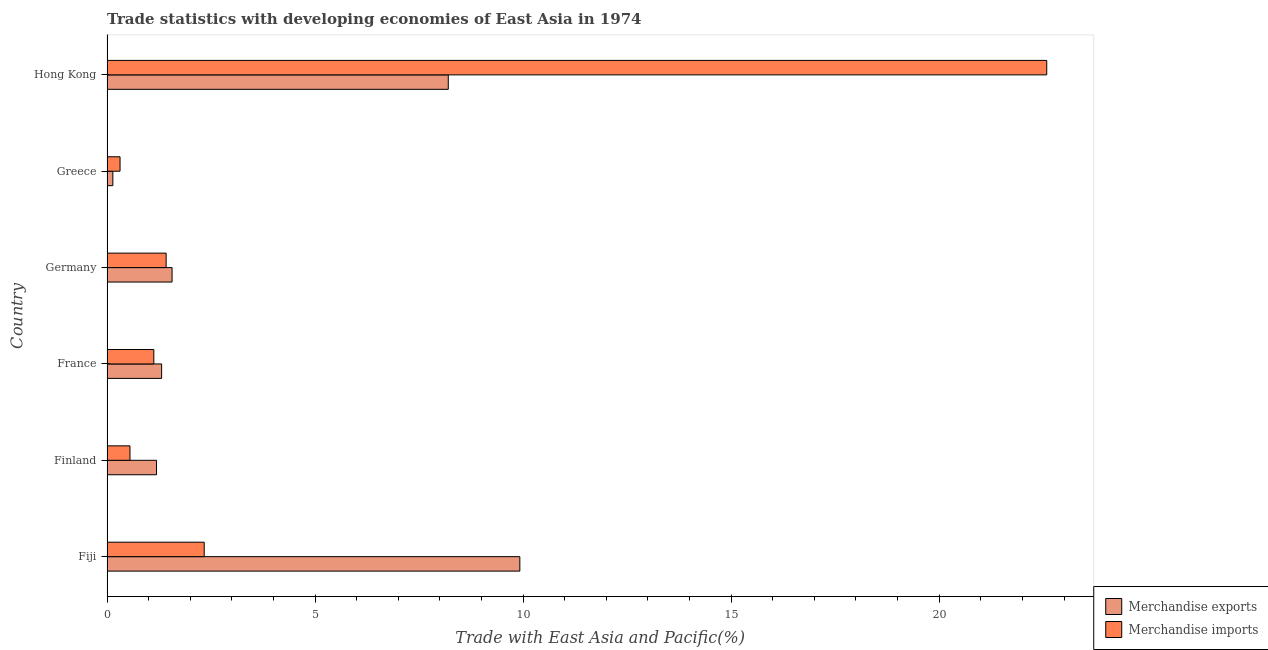How many different coloured bars are there?
Provide a succinct answer. 2. How many groups of bars are there?
Provide a short and direct response. 6. Are the number of bars per tick equal to the number of legend labels?
Your response must be concise. Yes. How many bars are there on the 3rd tick from the top?
Give a very brief answer. 2. How many bars are there on the 1st tick from the bottom?
Your response must be concise. 2. What is the label of the 1st group of bars from the top?
Ensure brevity in your answer.  Hong Kong. What is the merchandise exports in Finland?
Keep it short and to the point. 1.19. Across all countries, what is the maximum merchandise imports?
Make the answer very short. 22.59. Across all countries, what is the minimum merchandise imports?
Ensure brevity in your answer.  0.31. In which country was the merchandise exports maximum?
Offer a very short reply. Fiji. What is the total merchandise exports in the graph?
Your answer should be very brief. 22.33. What is the difference between the merchandise imports in Finland and that in Germany?
Make the answer very short. -0.87. What is the difference between the merchandise imports in Fiji and the merchandise exports in Hong Kong?
Give a very brief answer. -5.87. What is the average merchandise imports per country?
Provide a short and direct response. 4.72. What is the difference between the merchandise exports and merchandise imports in Finland?
Provide a succinct answer. 0.64. In how many countries, is the merchandise exports greater than 5 %?
Offer a very short reply. 2. What is the ratio of the merchandise imports in Finland to that in Greece?
Provide a short and direct response. 1.76. Is the merchandise exports in Fiji less than that in Finland?
Keep it short and to the point. No. What is the difference between the highest and the second highest merchandise imports?
Offer a very short reply. 20.25. What is the difference between the highest and the lowest merchandise imports?
Provide a succinct answer. 22.27. In how many countries, is the merchandise imports greater than the average merchandise imports taken over all countries?
Provide a short and direct response. 1. Is the sum of the merchandise exports in Germany and Hong Kong greater than the maximum merchandise imports across all countries?
Your response must be concise. No. What does the 1st bar from the top in Fiji represents?
Offer a very short reply. Merchandise imports. What is the difference between two consecutive major ticks on the X-axis?
Keep it short and to the point. 5. Are the values on the major ticks of X-axis written in scientific E-notation?
Your response must be concise. No. What is the title of the graph?
Keep it short and to the point. Trade statistics with developing economies of East Asia in 1974. What is the label or title of the X-axis?
Offer a very short reply. Trade with East Asia and Pacific(%). What is the label or title of the Y-axis?
Offer a terse response. Country. What is the Trade with East Asia and Pacific(%) of Merchandise exports in Fiji?
Make the answer very short. 9.92. What is the Trade with East Asia and Pacific(%) of Merchandise imports in Fiji?
Offer a terse response. 2.34. What is the Trade with East Asia and Pacific(%) in Merchandise exports in Finland?
Your answer should be compact. 1.19. What is the Trade with East Asia and Pacific(%) in Merchandise imports in Finland?
Make the answer very short. 0.55. What is the Trade with East Asia and Pacific(%) in Merchandise exports in France?
Give a very brief answer. 1.31. What is the Trade with East Asia and Pacific(%) in Merchandise imports in France?
Offer a very short reply. 1.13. What is the Trade with East Asia and Pacific(%) of Merchandise exports in Germany?
Offer a terse response. 1.56. What is the Trade with East Asia and Pacific(%) in Merchandise imports in Germany?
Make the answer very short. 1.42. What is the Trade with East Asia and Pacific(%) in Merchandise exports in Greece?
Offer a very short reply. 0.14. What is the Trade with East Asia and Pacific(%) in Merchandise imports in Greece?
Keep it short and to the point. 0.31. What is the Trade with East Asia and Pacific(%) of Merchandise exports in Hong Kong?
Your answer should be very brief. 8.2. What is the Trade with East Asia and Pacific(%) in Merchandise imports in Hong Kong?
Your response must be concise. 22.59. Across all countries, what is the maximum Trade with East Asia and Pacific(%) in Merchandise exports?
Provide a succinct answer. 9.92. Across all countries, what is the maximum Trade with East Asia and Pacific(%) of Merchandise imports?
Provide a short and direct response. 22.59. Across all countries, what is the minimum Trade with East Asia and Pacific(%) in Merchandise exports?
Make the answer very short. 0.14. Across all countries, what is the minimum Trade with East Asia and Pacific(%) of Merchandise imports?
Your answer should be very brief. 0.31. What is the total Trade with East Asia and Pacific(%) in Merchandise exports in the graph?
Offer a terse response. 22.33. What is the total Trade with East Asia and Pacific(%) of Merchandise imports in the graph?
Your answer should be very brief. 28.33. What is the difference between the Trade with East Asia and Pacific(%) in Merchandise exports in Fiji and that in Finland?
Your answer should be very brief. 8.73. What is the difference between the Trade with East Asia and Pacific(%) in Merchandise imports in Fiji and that in Finland?
Keep it short and to the point. 1.78. What is the difference between the Trade with East Asia and Pacific(%) in Merchandise exports in Fiji and that in France?
Make the answer very short. 8.61. What is the difference between the Trade with East Asia and Pacific(%) of Merchandise imports in Fiji and that in France?
Provide a succinct answer. 1.21. What is the difference between the Trade with East Asia and Pacific(%) of Merchandise exports in Fiji and that in Germany?
Make the answer very short. 8.36. What is the difference between the Trade with East Asia and Pacific(%) in Merchandise imports in Fiji and that in Germany?
Provide a succinct answer. 0.92. What is the difference between the Trade with East Asia and Pacific(%) in Merchandise exports in Fiji and that in Greece?
Your answer should be compact. 9.78. What is the difference between the Trade with East Asia and Pacific(%) of Merchandise imports in Fiji and that in Greece?
Make the answer very short. 2.02. What is the difference between the Trade with East Asia and Pacific(%) of Merchandise exports in Fiji and that in Hong Kong?
Offer a terse response. 1.72. What is the difference between the Trade with East Asia and Pacific(%) in Merchandise imports in Fiji and that in Hong Kong?
Your response must be concise. -20.25. What is the difference between the Trade with East Asia and Pacific(%) in Merchandise exports in Finland and that in France?
Your answer should be compact. -0.12. What is the difference between the Trade with East Asia and Pacific(%) in Merchandise imports in Finland and that in France?
Make the answer very short. -0.57. What is the difference between the Trade with East Asia and Pacific(%) of Merchandise exports in Finland and that in Germany?
Offer a very short reply. -0.37. What is the difference between the Trade with East Asia and Pacific(%) in Merchandise imports in Finland and that in Germany?
Your answer should be compact. -0.87. What is the difference between the Trade with East Asia and Pacific(%) of Merchandise exports in Finland and that in Greece?
Provide a succinct answer. 1.05. What is the difference between the Trade with East Asia and Pacific(%) of Merchandise imports in Finland and that in Greece?
Your response must be concise. 0.24. What is the difference between the Trade with East Asia and Pacific(%) in Merchandise exports in Finland and that in Hong Kong?
Your answer should be compact. -7.01. What is the difference between the Trade with East Asia and Pacific(%) in Merchandise imports in Finland and that in Hong Kong?
Offer a terse response. -22.03. What is the difference between the Trade with East Asia and Pacific(%) in Merchandise exports in France and that in Germany?
Offer a very short reply. -0.25. What is the difference between the Trade with East Asia and Pacific(%) of Merchandise imports in France and that in Germany?
Provide a succinct answer. -0.3. What is the difference between the Trade with East Asia and Pacific(%) in Merchandise exports in France and that in Greece?
Make the answer very short. 1.17. What is the difference between the Trade with East Asia and Pacific(%) of Merchandise imports in France and that in Greece?
Provide a short and direct response. 0.81. What is the difference between the Trade with East Asia and Pacific(%) in Merchandise exports in France and that in Hong Kong?
Ensure brevity in your answer.  -6.89. What is the difference between the Trade with East Asia and Pacific(%) of Merchandise imports in France and that in Hong Kong?
Your answer should be compact. -21.46. What is the difference between the Trade with East Asia and Pacific(%) in Merchandise exports in Germany and that in Greece?
Offer a terse response. 1.42. What is the difference between the Trade with East Asia and Pacific(%) of Merchandise imports in Germany and that in Greece?
Offer a very short reply. 1.11. What is the difference between the Trade with East Asia and Pacific(%) in Merchandise exports in Germany and that in Hong Kong?
Provide a short and direct response. -6.64. What is the difference between the Trade with East Asia and Pacific(%) of Merchandise imports in Germany and that in Hong Kong?
Offer a very short reply. -21.16. What is the difference between the Trade with East Asia and Pacific(%) of Merchandise exports in Greece and that in Hong Kong?
Offer a terse response. -8.06. What is the difference between the Trade with East Asia and Pacific(%) of Merchandise imports in Greece and that in Hong Kong?
Ensure brevity in your answer.  -22.27. What is the difference between the Trade with East Asia and Pacific(%) in Merchandise exports in Fiji and the Trade with East Asia and Pacific(%) in Merchandise imports in Finland?
Your answer should be very brief. 9.37. What is the difference between the Trade with East Asia and Pacific(%) in Merchandise exports in Fiji and the Trade with East Asia and Pacific(%) in Merchandise imports in France?
Provide a short and direct response. 8.8. What is the difference between the Trade with East Asia and Pacific(%) of Merchandise exports in Fiji and the Trade with East Asia and Pacific(%) of Merchandise imports in Germany?
Offer a terse response. 8.5. What is the difference between the Trade with East Asia and Pacific(%) in Merchandise exports in Fiji and the Trade with East Asia and Pacific(%) in Merchandise imports in Greece?
Offer a very short reply. 9.61. What is the difference between the Trade with East Asia and Pacific(%) of Merchandise exports in Fiji and the Trade with East Asia and Pacific(%) of Merchandise imports in Hong Kong?
Ensure brevity in your answer.  -12.66. What is the difference between the Trade with East Asia and Pacific(%) of Merchandise exports in Finland and the Trade with East Asia and Pacific(%) of Merchandise imports in France?
Give a very brief answer. 0.06. What is the difference between the Trade with East Asia and Pacific(%) of Merchandise exports in Finland and the Trade with East Asia and Pacific(%) of Merchandise imports in Germany?
Provide a short and direct response. -0.23. What is the difference between the Trade with East Asia and Pacific(%) of Merchandise exports in Finland and the Trade with East Asia and Pacific(%) of Merchandise imports in Greece?
Keep it short and to the point. 0.88. What is the difference between the Trade with East Asia and Pacific(%) in Merchandise exports in Finland and the Trade with East Asia and Pacific(%) in Merchandise imports in Hong Kong?
Ensure brevity in your answer.  -21.4. What is the difference between the Trade with East Asia and Pacific(%) of Merchandise exports in France and the Trade with East Asia and Pacific(%) of Merchandise imports in Germany?
Your answer should be very brief. -0.11. What is the difference between the Trade with East Asia and Pacific(%) in Merchandise exports in France and the Trade with East Asia and Pacific(%) in Merchandise imports in Hong Kong?
Offer a terse response. -21.27. What is the difference between the Trade with East Asia and Pacific(%) in Merchandise exports in Germany and the Trade with East Asia and Pacific(%) in Merchandise imports in Greece?
Make the answer very short. 1.25. What is the difference between the Trade with East Asia and Pacific(%) in Merchandise exports in Germany and the Trade with East Asia and Pacific(%) in Merchandise imports in Hong Kong?
Your answer should be compact. -21.02. What is the difference between the Trade with East Asia and Pacific(%) of Merchandise exports in Greece and the Trade with East Asia and Pacific(%) of Merchandise imports in Hong Kong?
Make the answer very short. -22.44. What is the average Trade with East Asia and Pacific(%) of Merchandise exports per country?
Offer a terse response. 3.72. What is the average Trade with East Asia and Pacific(%) of Merchandise imports per country?
Make the answer very short. 4.72. What is the difference between the Trade with East Asia and Pacific(%) in Merchandise exports and Trade with East Asia and Pacific(%) in Merchandise imports in Fiji?
Your response must be concise. 7.59. What is the difference between the Trade with East Asia and Pacific(%) of Merchandise exports and Trade with East Asia and Pacific(%) of Merchandise imports in Finland?
Provide a short and direct response. 0.64. What is the difference between the Trade with East Asia and Pacific(%) in Merchandise exports and Trade with East Asia and Pacific(%) in Merchandise imports in France?
Ensure brevity in your answer.  0.19. What is the difference between the Trade with East Asia and Pacific(%) in Merchandise exports and Trade with East Asia and Pacific(%) in Merchandise imports in Germany?
Make the answer very short. 0.14. What is the difference between the Trade with East Asia and Pacific(%) of Merchandise exports and Trade with East Asia and Pacific(%) of Merchandise imports in Greece?
Offer a terse response. -0.17. What is the difference between the Trade with East Asia and Pacific(%) of Merchandise exports and Trade with East Asia and Pacific(%) of Merchandise imports in Hong Kong?
Provide a short and direct response. -14.38. What is the ratio of the Trade with East Asia and Pacific(%) in Merchandise exports in Fiji to that in Finland?
Your answer should be compact. 8.34. What is the ratio of the Trade with East Asia and Pacific(%) in Merchandise imports in Fiji to that in Finland?
Make the answer very short. 4.23. What is the ratio of the Trade with East Asia and Pacific(%) of Merchandise exports in Fiji to that in France?
Make the answer very short. 7.56. What is the ratio of the Trade with East Asia and Pacific(%) in Merchandise imports in Fiji to that in France?
Offer a very short reply. 2.08. What is the ratio of the Trade with East Asia and Pacific(%) of Merchandise exports in Fiji to that in Germany?
Offer a very short reply. 6.35. What is the ratio of the Trade with East Asia and Pacific(%) of Merchandise imports in Fiji to that in Germany?
Give a very brief answer. 1.64. What is the ratio of the Trade with East Asia and Pacific(%) of Merchandise exports in Fiji to that in Greece?
Provide a succinct answer. 70.66. What is the ratio of the Trade with East Asia and Pacific(%) in Merchandise imports in Fiji to that in Greece?
Your answer should be very brief. 7.45. What is the ratio of the Trade with East Asia and Pacific(%) in Merchandise exports in Fiji to that in Hong Kong?
Give a very brief answer. 1.21. What is the ratio of the Trade with East Asia and Pacific(%) in Merchandise imports in Fiji to that in Hong Kong?
Your response must be concise. 0.1. What is the ratio of the Trade with East Asia and Pacific(%) of Merchandise exports in Finland to that in France?
Provide a succinct answer. 0.91. What is the ratio of the Trade with East Asia and Pacific(%) of Merchandise imports in Finland to that in France?
Ensure brevity in your answer.  0.49. What is the ratio of the Trade with East Asia and Pacific(%) of Merchandise exports in Finland to that in Germany?
Ensure brevity in your answer.  0.76. What is the ratio of the Trade with East Asia and Pacific(%) of Merchandise imports in Finland to that in Germany?
Keep it short and to the point. 0.39. What is the ratio of the Trade with East Asia and Pacific(%) in Merchandise exports in Finland to that in Greece?
Offer a very short reply. 8.47. What is the ratio of the Trade with East Asia and Pacific(%) of Merchandise imports in Finland to that in Greece?
Make the answer very short. 1.76. What is the ratio of the Trade with East Asia and Pacific(%) in Merchandise exports in Finland to that in Hong Kong?
Keep it short and to the point. 0.15. What is the ratio of the Trade with East Asia and Pacific(%) in Merchandise imports in Finland to that in Hong Kong?
Your answer should be compact. 0.02. What is the ratio of the Trade with East Asia and Pacific(%) of Merchandise exports in France to that in Germany?
Ensure brevity in your answer.  0.84. What is the ratio of the Trade with East Asia and Pacific(%) in Merchandise imports in France to that in Germany?
Offer a terse response. 0.79. What is the ratio of the Trade with East Asia and Pacific(%) of Merchandise exports in France to that in Greece?
Provide a succinct answer. 9.35. What is the ratio of the Trade with East Asia and Pacific(%) in Merchandise imports in France to that in Greece?
Keep it short and to the point. 3.59. What is the ratio of the Trade with East Asia and Pacific(%) of Merchandise exports in France to that in Hong Kong?
Ensure brevity in your answer.  0.16. What is the ratio of the Trade with East Asia and Pacific(%) of Merchandise imports in France to that in Hong Kong?
Keep it short and to the point. 0.05. What is the ratio of the Trade with East Asia and Pacific(%) of Merchandise exports in Germany to that in Greece?
Your answer should be very brief. 11.14. What is the ratio of the Trade with East Asia and Pacific(%) in Merchandise imports in Germany to that in Greece?
Your answer should be very brief. 4.54. What is the ratio of the Trade with East Asia and Pacific(%) in Merchandise exports in Germany to that in Hong Kong?
Offer a very short reply. 0.19. What is the ratio of the Trade with East Asia and Pacific(%) in Merchandise imports in Germany to that in Hong Kong?
Ensure brevity in your answer.  0.06. What is the ratio of the Trade with East Asia and Pacific(%) of Merchandise exports in Greece to that in Hong Kong?
Keep it short and to the point. 0.02. What is the ratio of the Trade with East Asia and Pacific(%) of Merchandise imports in Greece to that in Hong Kong?
Your answer should be compact. 0.01. What is the difference between the highest and the second highest Trade with East Asia and Pacific(%) of Merchandise exports?
Provide a succinct answer. 1.72. What is the difference between the highest and the second highest Trade with East Asia and Pacific(%) in Merchandise imports?
Offer a very short reply. 20.25. What is the difference between the highest and the lowest Trade with East Asia and Pacific(%) of Merchandise exports?
Provide a succinct answer. 9.78. What is the difference between the highest and the lowest Trade with East Asia and Pacific(%) of Merchandise imports?
Your answer should be compact. 22.27. 